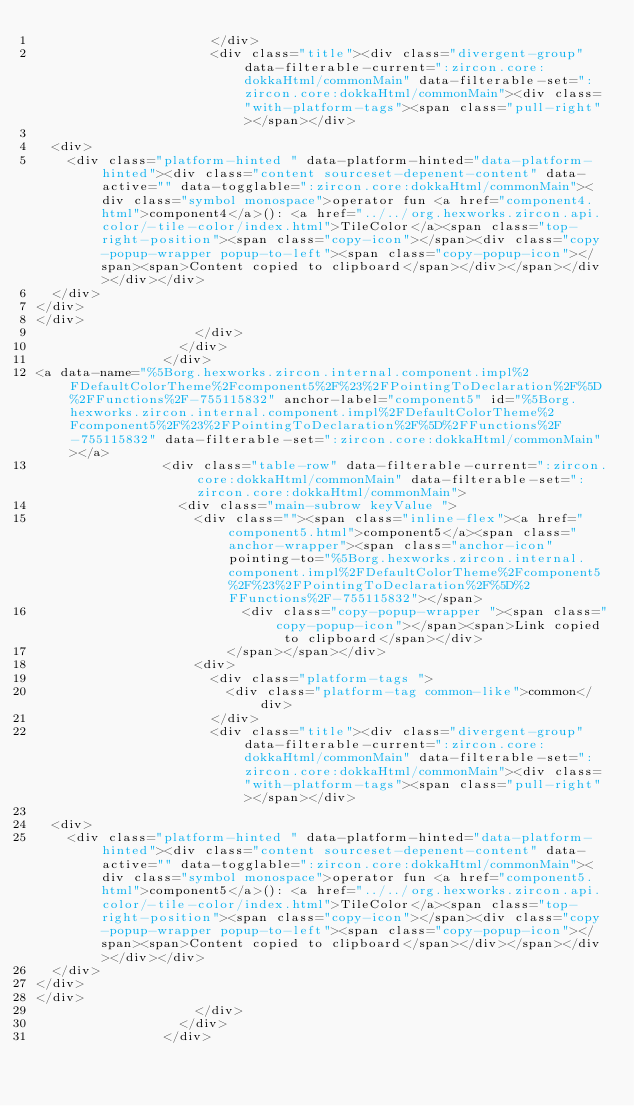<code> <loc_0><loc_0><loc_500><loc_500><_HTML_>                      </div>
                      <div class="title"><div class="divergent-group" data-filterable-current=":zircon.core:dokkaHtml/commonMain" data-filterable-set=":zircon.core:dokkaHtml/commonMain"><div class="with-platform-tags"><span class="pull-right"></span></div>

  <div>
    <div class="platform-hinted " data-platform-hinted="data-platform-hinted"><div class="content sourceset-depenent-content" data-active="" data-togglable=":zircon.core:dokkaHtml/commonMain"><div class="symbol monospace">operator fun <a href="component4.html">component4</a>(): <a href="../../org.hexworks.zircon.api.color/-tile-color/index.html">TileColor</a><span class="top-right-position"><span class="copy-icon"></span><div class="copy-popup-wrapper popup-to-left"><span class="copy-popup-icon"></span><span>Content copied to clipboard</span></div></span></div></div></div>
  </div>
</div>
</div>
                    </div>
                  </div>
                </div>
<a data-name="%5Borg.hexworks.zircon.internal.component.impl%2FDefaultColorTheme%2Fcomponent5%2F%23%2FPointingToDeclaration%2F%5D%2FFunctions%2F-755115832" anchor-label="component5" id="%5Borg.hexworks.zircon.internal.component.impl%2FDefaultColorTheme%2Fcomponent5%2F%23%2FPointingToDeclaration%2F%5D%2FFunctions%2F-755115832" data-filterable-set=":zircon.core:dokkaHtml/commonMain"></a>
                <div class="table-row" data-filterable-current=":zircon.core:dokkaHtml/commonMain" data-filterable-set=":zircon.core:dokkaHtml/commonMain">
                  <div class="main-subrow keyValue ">
                    <div class=""><span class="inline-flex"><a href="component5.html">component5</a><span class="anchor-wrapper"><span class="anchor-icon" pointing-to="%5Borg.hexworks.zircon.internal.component.impl%2FDefaultColorTheme%2Fcomponent5%2F%23%2FPointingToDeclaration%2F%5D%2FFunctions%2F-755115832"></span>
                          <div class="copy-popup-wrapper "><span class="copy-popup-icon"></span><span>Link copied to clipboard</span></div>
                        </span></span></div>
                    <div>
                      <div class="platform-tags ">
                        <div class="platform-tag common-like">common</div>
                      </div>
                      <div class="title"><div class="divergent-group" data-filterable-current=":zircon.core:dokkaHtml/commonMain" data-filterable-set=":zircon.core:dokkaHtml/commonMain"><div class="with-platform-tags"><span class="pull-right"></span></div>

  <div>
    <div class="platform-hinted " data-platform-hinted="data-platform-hinted"><div class="content sourceset-depenent-content" data-active="" data-togglable=":zircon.core:dokkaHtml/commonMain"><div class="symbol monospace">operator fun <a href="component5.html">component5</a>(): <a href="../../org.hexworks.zircon.api.color/-tile-color/index.html">TileColor</a><span class="top-right-position"><span class="copy-icon"></span><div class="copy-popup-wrapper popup-to-left"><span class="copy-popup-icon"></span><span>Content copied to clipboard</span></div></span></div></div></div>
  </div>
</div>
</div>
                    </div>
                  </div>
                </div></code> 